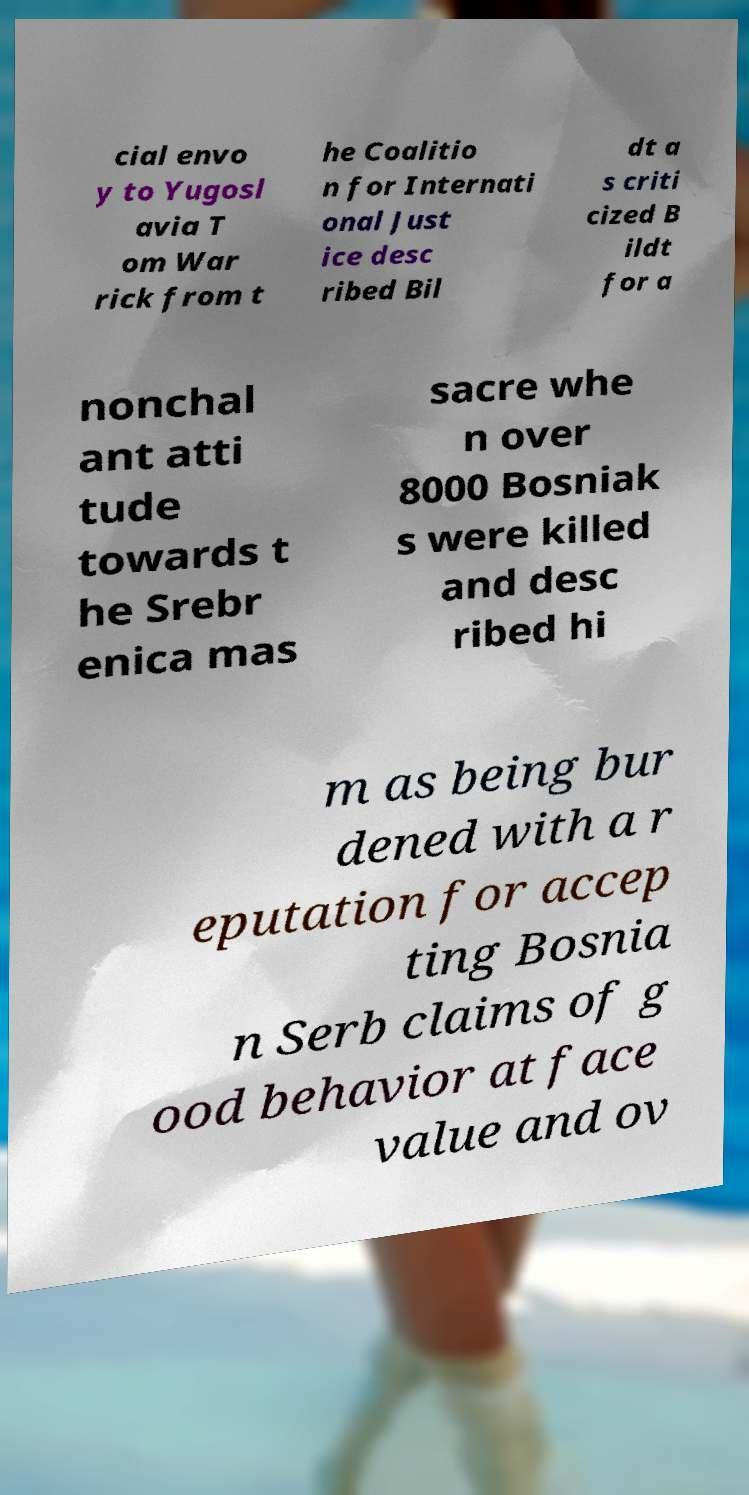For documentation purposes, I need the text within this image transcribed. Could you provide that? cial envo y to Yugosl avia T om War rick from t he Coalitio n for Internati onal Just ice desc ribed Bil dt a s criti cized B ildt for a nonchal ant atti tude towards t he Srebr enica mas sacre whe n over 8000 Bosniak s were killed and desc ribed hi m as being bur dened with a r eputation for accep ting Bosnia n Serb claims of g ood behavior at face value and ov 